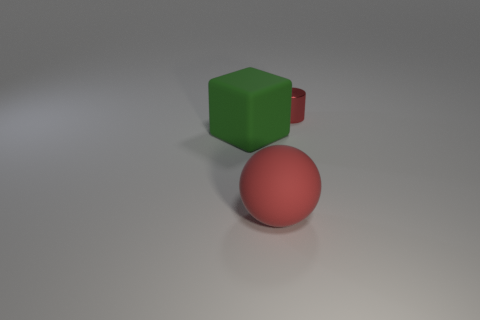There is a thing that is behind the red rubber ball and in front of the small cylinder; what shape is it?
Your answer should be very brief. Cube. How many large things are the same material as the cube?
Ensure brevity in your answer.  1. There is a large rubber sphere; does it have the same color as the rubber object that is behind the big red rubber object?
Keep it short and to the point. No. Are there more balls than objects?
Keep it short and to the point. No. What color is the large matte ball?
Your response must be concise. Red. There is a small object behind the red rubber object; does it have the same color as the big matte cube?
Your answer should be compact. No. There is a tiny thing that is the same color as the large rubber sphere; what is it made of?
Offer a terse response. Metal. What number of matte spheres are the same color as the small object?
Your answer should be very brief. 1. Do the red object in front of the tiny red metal cylinder and the big green object have the same shape?
Your answer should be very brief. No. Is the number of red metallic cylinders left of the large green matte object less than the number of big red objects that are in front of the rubber sphere?
Make the answer very short. No. 